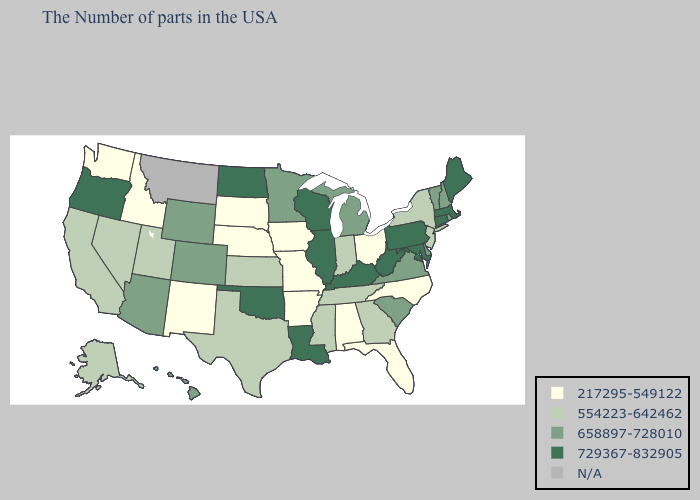Name the states that have a value in the range 554223-642462?
Give a very brief answer. New York, New Jersey, Georgia, Indiana, Tennessee, Mississippi, Kansas, Texas, Utah, Nevada, California, Alaska. What is the value of Michigan?
Quick response, please. 658897-728010. Name the states that have a value in the range 554223-642462?
Be succinct. New York, New Jersey, Georgia, Indiana, Tennessee, Mississippi, Kansas, Texas, Utah, Nevada, California, Alaska. What is the value of Minnesota?
Answer briefly. 658897-728010. Does California have the lowest value in the USA?
Write a very short answer. No. Which states have the highest value in the USA?
Give a very brief answer. Maine, Massachusetts, Connecticut, Maryland, Pennsylvania, West Virginia, Kentucky, Wisconsin, Illinois, Louisiana, Oklahoma, North Dakota, Oregon. What is the value of Maine?
Quick response, please. 729367-832905. Does Idaho have the highest value in the USA?
Short answer required. No. Name the states that have a value in the range 658897-728010?
Concise answer only. Rhode Island, New Hampshire, Vermont, Delaware, Virginia, South Carolina, Michigan, Minnesota, Wyoming, Colorado, Arizona, Hawaii. What is the lowest value in states that border Kansas?
Be succinct. 217295-549122. Which states hav the highest value in the MidWest?
Short answer required. Wisconsin, Illinois, North Dakota. Does the map have missing data?
Short answer required. Yes. 